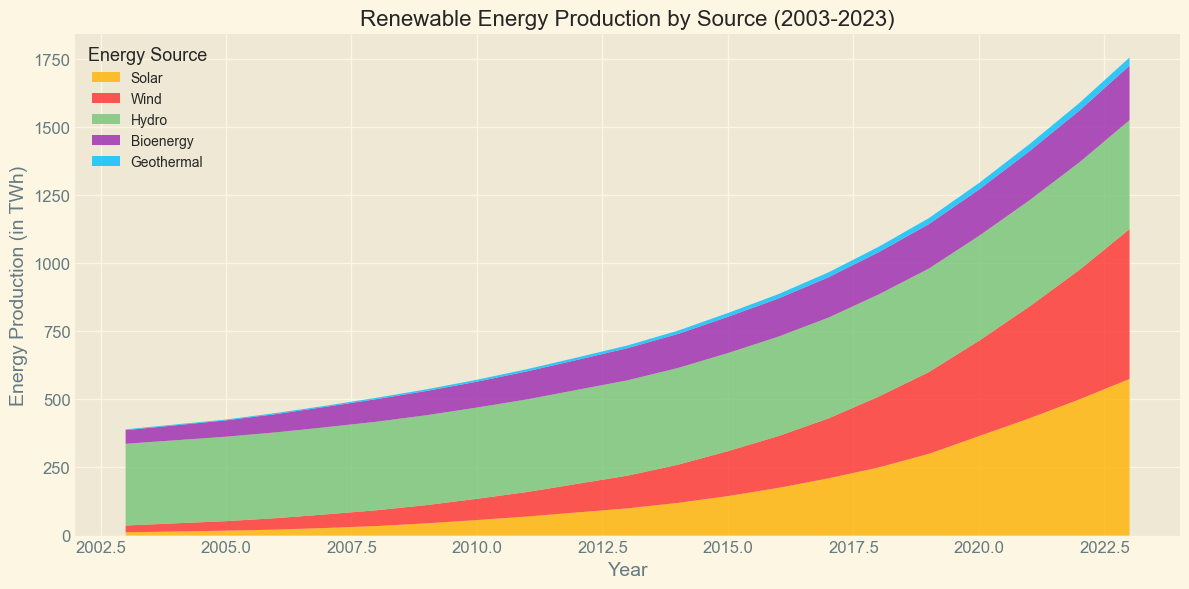What source had the highest energy production in 2023? The highest energy production for a source in 2023 can be seen by looking at the top layer of the area chart, which represents the maximum value and its corresponding source. The topmost color in the chart for 2023 represents Wind, which is highest.
Answer: Wind Which source showed the most consistent increase over the 20 years? All sources appear to increase, but some may have fluctuations or steeper growth at certain periods. Observing the smoothest gradient over the years, Hydro shows the most steady and consistent increase without sharp jumps or dips.
Answer: Hydro How much energy was produced by Solar and Wind combined in 2015? To find the combined energy production of Solar and Wind in 2015, add their individual productions: Solar produced 145 TWh and Wind produced 165 TWh. So, 145 + 165 = 310 TWh.
Answer: 310 TWh Compare the increase in production for Bioenergy and Geothermal from 2010 to 2023. Which one had a higher increase and by how much? To compare, subtract the 2010 value from the 2023 value for both sources: Bioenergy increased from 95 to 200 (200 - 95 = 105) and Geothermal increased from 7 to 30 (30 - 7 = 23). The increase for Bioenergy is 105 - 23 = 82 TWh more.
Answer: Bioenergy by 82 TWh Which year did Wind energy surpass Hydro energy in production? To determine the year Wind energy surpassed Hydro energy, look for when the red area (Wind) overtakes the green area (Hydro). It visually appears Wind energy surpassed Hydro around 2018.
Answer: 2018 Between 2003 and 2020, in which year did Solar energy have the highest relative increase compared to the previous year? The highest relative increase can be found by calculating the difference in Solar energy year-over-year and identifying the maximum: 
- 2004 (15 - 12 = 3)
- 2008 (35 - 28 = 7)
- 2014 (120 - 100 = 20)
The highest relative increase occurred between 2019 and 2020, with an increase of (365 - 300 = 65).
Answer: 2020 What percentage of total renewable energy production did Wind account for in 2023? To find the percentage of total renewable energy produced by Wind in 2023, first find the total production: Solar (575) + Wind (550) + Hydro (400) + Bioenergy (200) + Geothermal (30) = 1755 TWh. Then, calculate the percentage Wind contributed: (550 / 1755) * 100 ≈ 31.35%.
Answer: 31.35% What was the trend of Geothermal energy production from 2003 to 2023? Geothermal energy had a steady but relatively small increase over the years, starting at 3 TWh in 2003 and gradually rising to 30 TWh by 2023. This indicates a slow and continuous growing trend.
Answer: Steady increase 